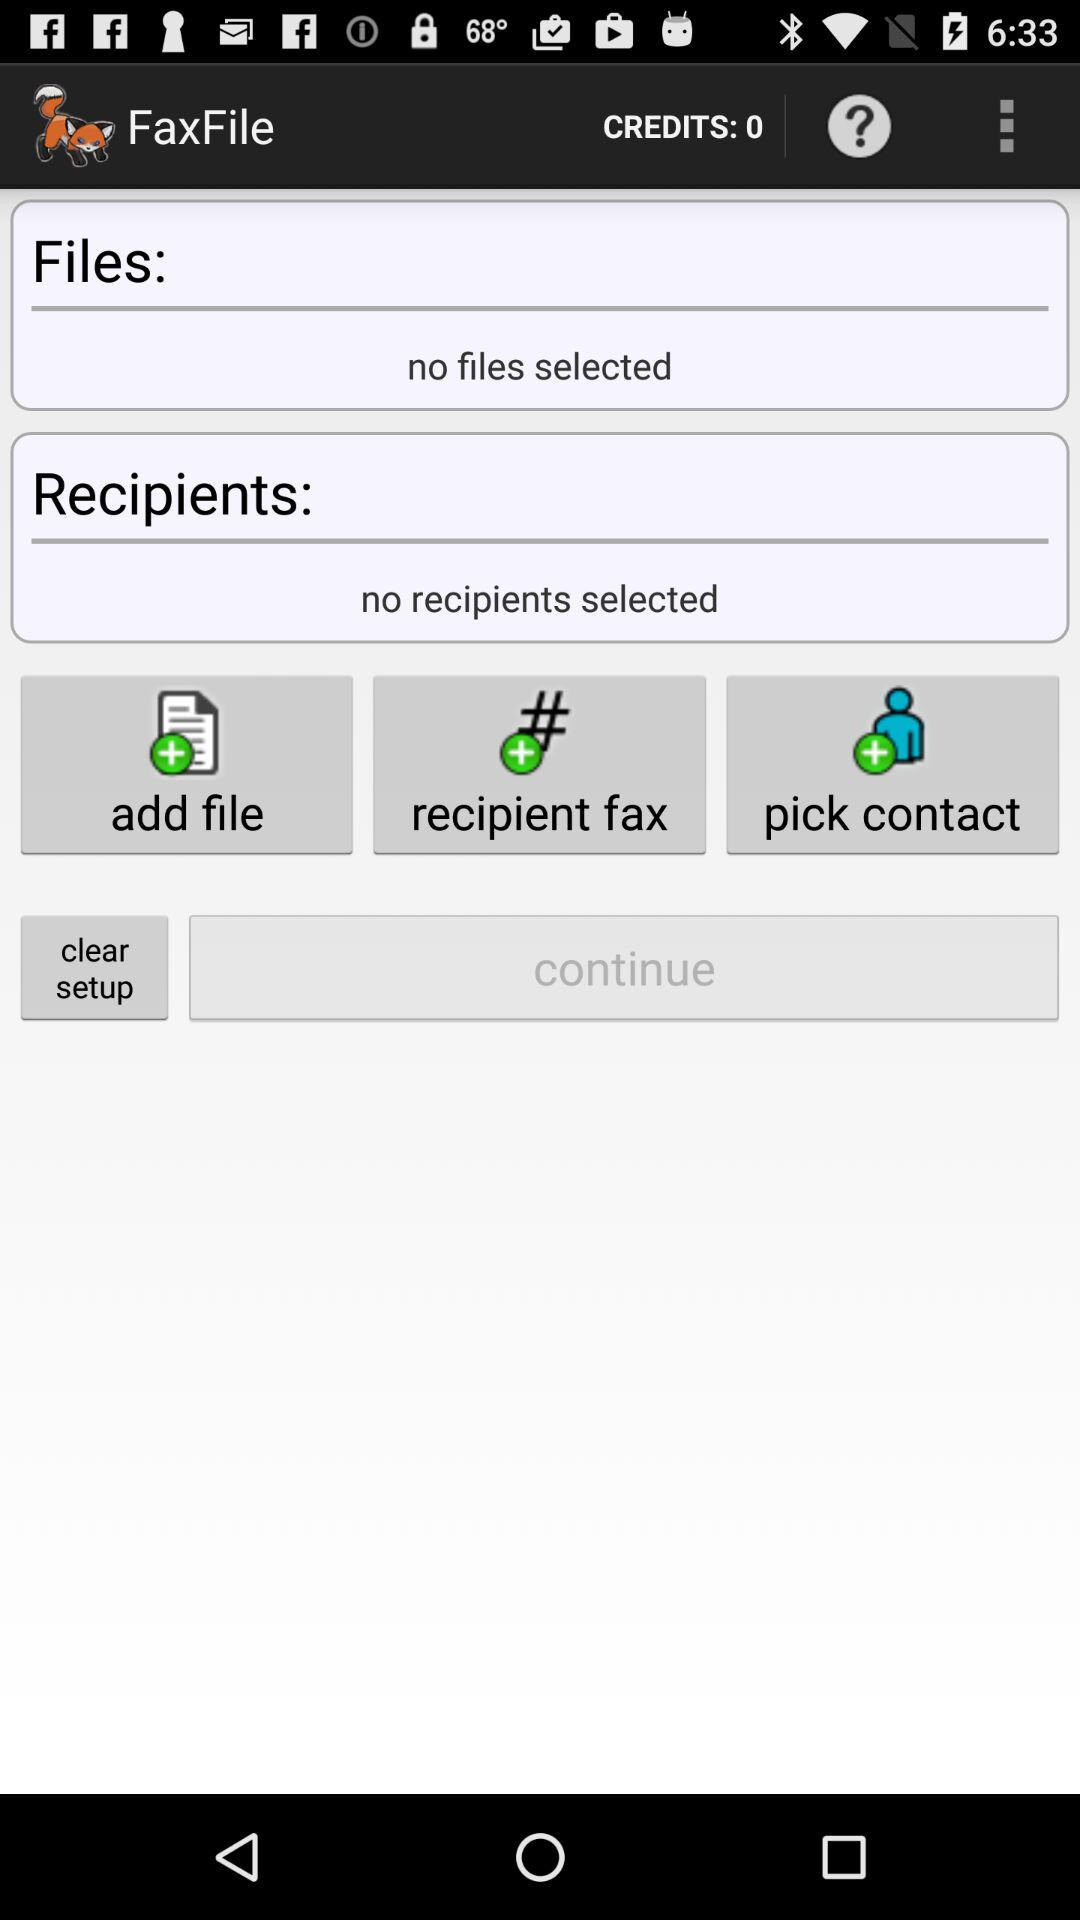How many recipients have been selected? There are no selected recipients. 